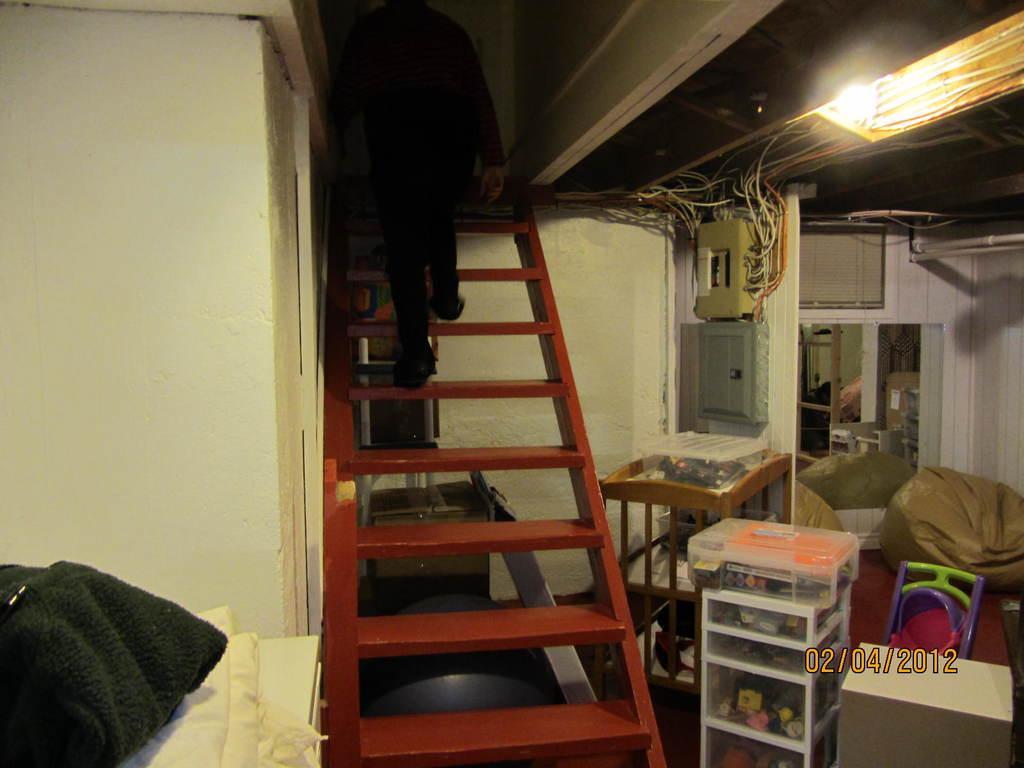In one or two sentences, can you explain what this image depicts? A picture inside of a room. This person is on steps. On top there is a light. These are cables. On a cart there is a box. This is a bean bag. Wall is in white color. 